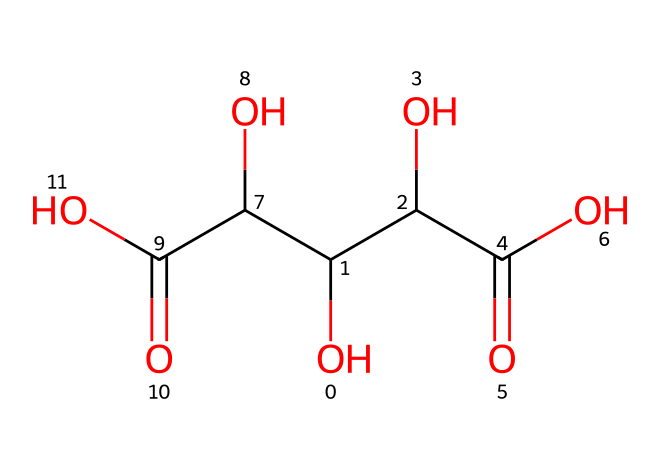What is the molecular formula of tartaric acid? By analyzing the structure represented in the SMILES, we can identify the number of each type of atom present. The breakdown shows there are 4 carbons (C), 6 hydrogens (H), and 4 oxygens (O), leading to the molecular formula of C4H6O6.
Answer: C4H6O6 How many hydroxyl (OH) groups are present in tartaric acid? The structure indicates there are two hydroxyl groups (identified as –OH) attached to the carbon backbone of the molecule. This can be counted directly from the visual representation.
Answer: 2 What is the main functional group in tartaric acid? Tartaric acid primarily contains carboxylic acid functional groups (represented as –COOH). An examination of the structure shows there are two carboxylic acid groups present.
Answer: carboxylic acid How does the presence of multiple hydroxyl groups affect the solubility of tartaric acid? The presence of multiple hydroxyl groups in tartaric acid enhances its solubility in water due to hydrogen bonding capabilities. Each hydroxyl group can form hydrogen bonds with water molecules, increasing solubility.
Answer: increases solubility What structural feature of tartaric acid contributes to its crystalline form? The ability of tartaric acid to form extensive hydrogen bonds due to its hydroxyl and carboxylic acid groups facilitates the formation of a stable crystalline lattice structure in its solid state.
Answer: hydrogen bonding How many chiral centers are present in tartaric acid? Analyzing the molecular structure shows that there are two carbon atoms that are attached to four different groups, making them chiral centers. This results in tartaric acid having two chiral centers.
Answer: 2 